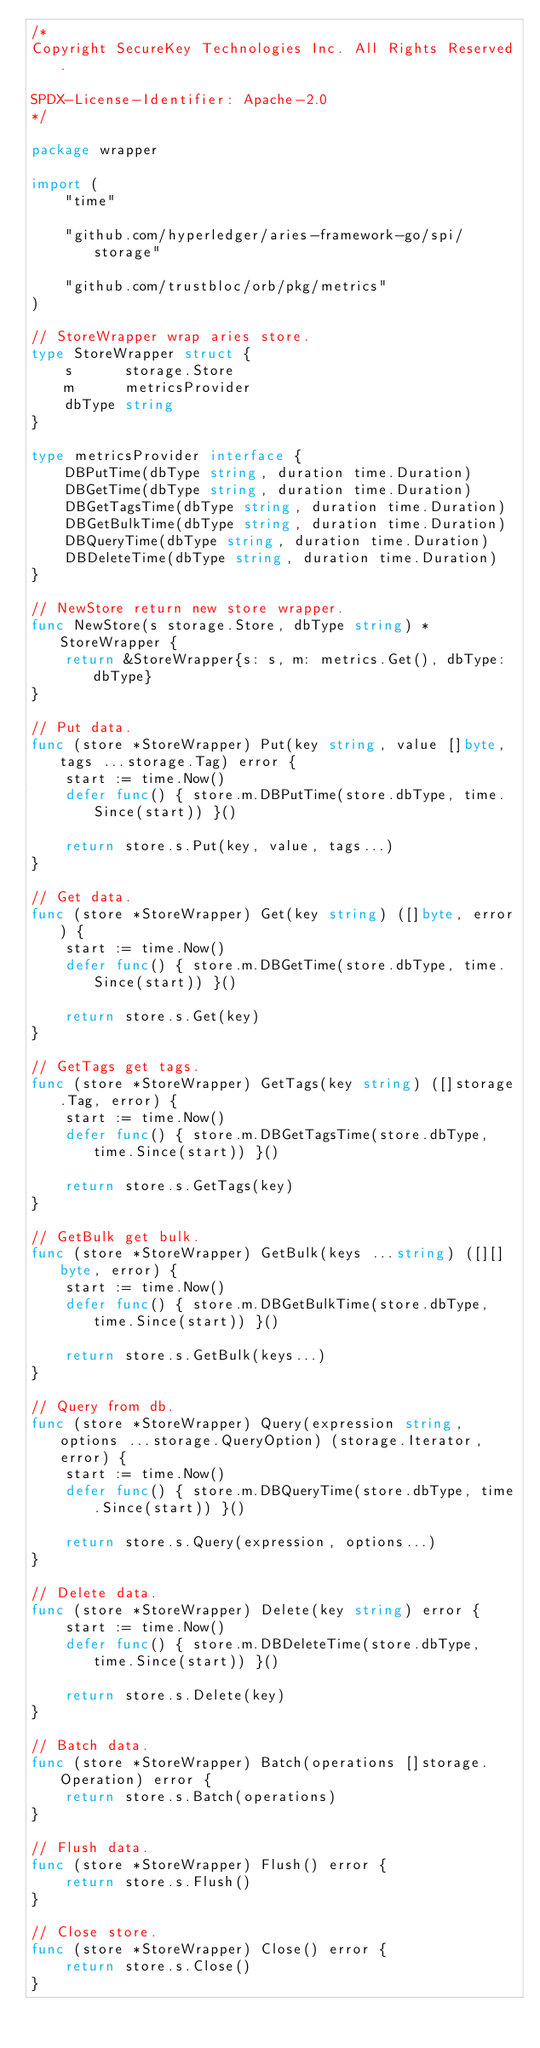<code> <loc_0><loc_0><loc_500><loc_500><_Go_>/*
Copyright SecureKey Technologies Inc. All Rights Reserved.

SPDX-License-Identifier: Apache-2.0
*/

package wrapper

import (
	"time"

	"github.com/hyperledger/aries-framework-go/spi/storage"

	"github.com/trustbloc/orb/pkg/metrics"
)

// StoreWrapper wrap aries store.
type StoreWrapper struct {
	s      storage.Store
	m      metricsProvider
	dbType string
}

type metricsProvider interface {
	DBPutTime(dbType string, duration time.Duration)
	DBGetTime(dbType string, duration time.Duration)
	DBGetTagsTime(dbType string, duration time.Duration)
	DBGetBulkTime(dbType string, duration time.Duration)
	DBQueryTime(dbType string, duration time.Duration)
	DBDeleteTime(dbType string, duration time.Duration)
}

// NewStore return new store wrapper.
func NewStore(s storage.Store, dbType string) *StoreWrapper {
	return &StoreWrapper{s: s, m: metrics.Get(), dbType: dbType}
}

// Put data.
func (store *StoreWrapper) Put(key string, value []byte, tags ...storage.Tag) error {
	start := time.Now()
	defer func() { store.m.DBPutTime(store.dbType, time.Since(start)) }()

	return store.s.Put(key, value, tags...)
}

// Get data.
func (store *StoreWrapper) Get(key string) ([]byte, error) {
	start := time.Now()
	defer func() { store.m.DBGetTime(store.dbType, time.Since(start)) }()

	return store.s.Get(key)
}

// GetTags get tags.
func (store *StoreWrapper) GetTags(key string) ([]storage.Tag, error) {
	start := time.Now()
	defer func() { store.m.DBGetTagsTime(store.dbType, time.Since(start)) }()

	return store.s.GetTags(key)
}

// GetBulk get bulk.
func (store *StoreWrapper) GetBulk(keys ...string) ([][]byte, error) {
	start := time.Now()
	defer func() { store.m.DBGetBulkTime(store.dbType, time.Since(start)) }()

	return store.s.GetBulk(keys...)
}

// Query from db.
func (store *StoreWrapper) Query(expression string, options ...storage.QueryOption) (storage.Iterator, error) {
	start := time.Now()
	defer func() { store.m.DBQueryTime(store.dbType, time.Since(start)) }()

	return store.s.Query(expression, options...)
}

// Delete data.
func (store *StoreWrapper) Delete(key string) error {
	start := time.Now()
	defer func() { store.m.DBDeleteTime(store.dbType, time.Since(start)) }()

	return store.s.Delete(key)
}

// Batch data.
func (store *StoreWrapper) Batch(operations []storage.Operation) error {
	return store.s.Batch(operations)
}

// Flush data.
func (store *StoreWrapper) Flush() error {
	return store.s.Flush()
}

// Close store.
func (store *StoreWrapper) Close() error {
	return store.s.Close()
}
</code> 